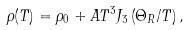Convert formula to latex. <formula><loc_0><loc_0><loc_500><loc_500>\rho ( T ) = \rho _ { 0 } + A T ^ { 3 } J _ { 3 } \left ( { \Theta _ { R } / T } \right ) ,</formula> 